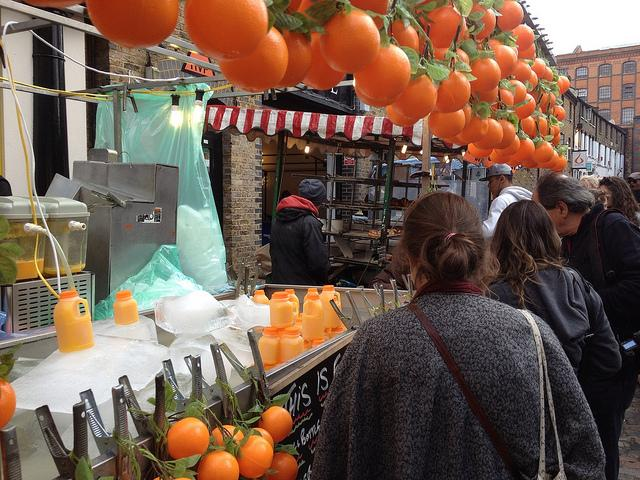The orange orbs seen here are actually what? Please explain your reasoning. plastic. The orbs are plastic. 